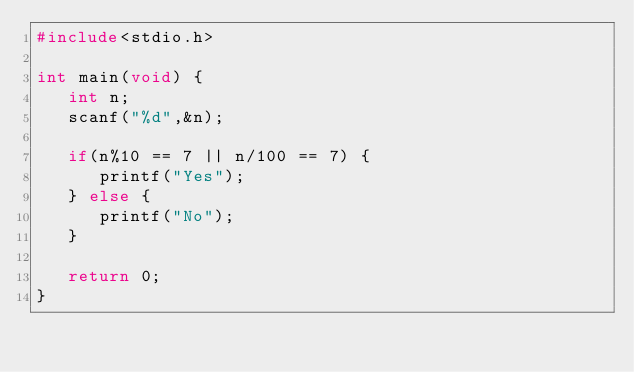<code> <loc_0><loc_0><loc_500><loc_500><_C_>#include<stdio.h>

int main(void) {
   int n;
   scanf("%d",&n);

   if(n%10 == 7 || n/100 == 7) {
      printf("Yes");
   } else {
      printf("No");
   }

   return 0;
}
</code> 